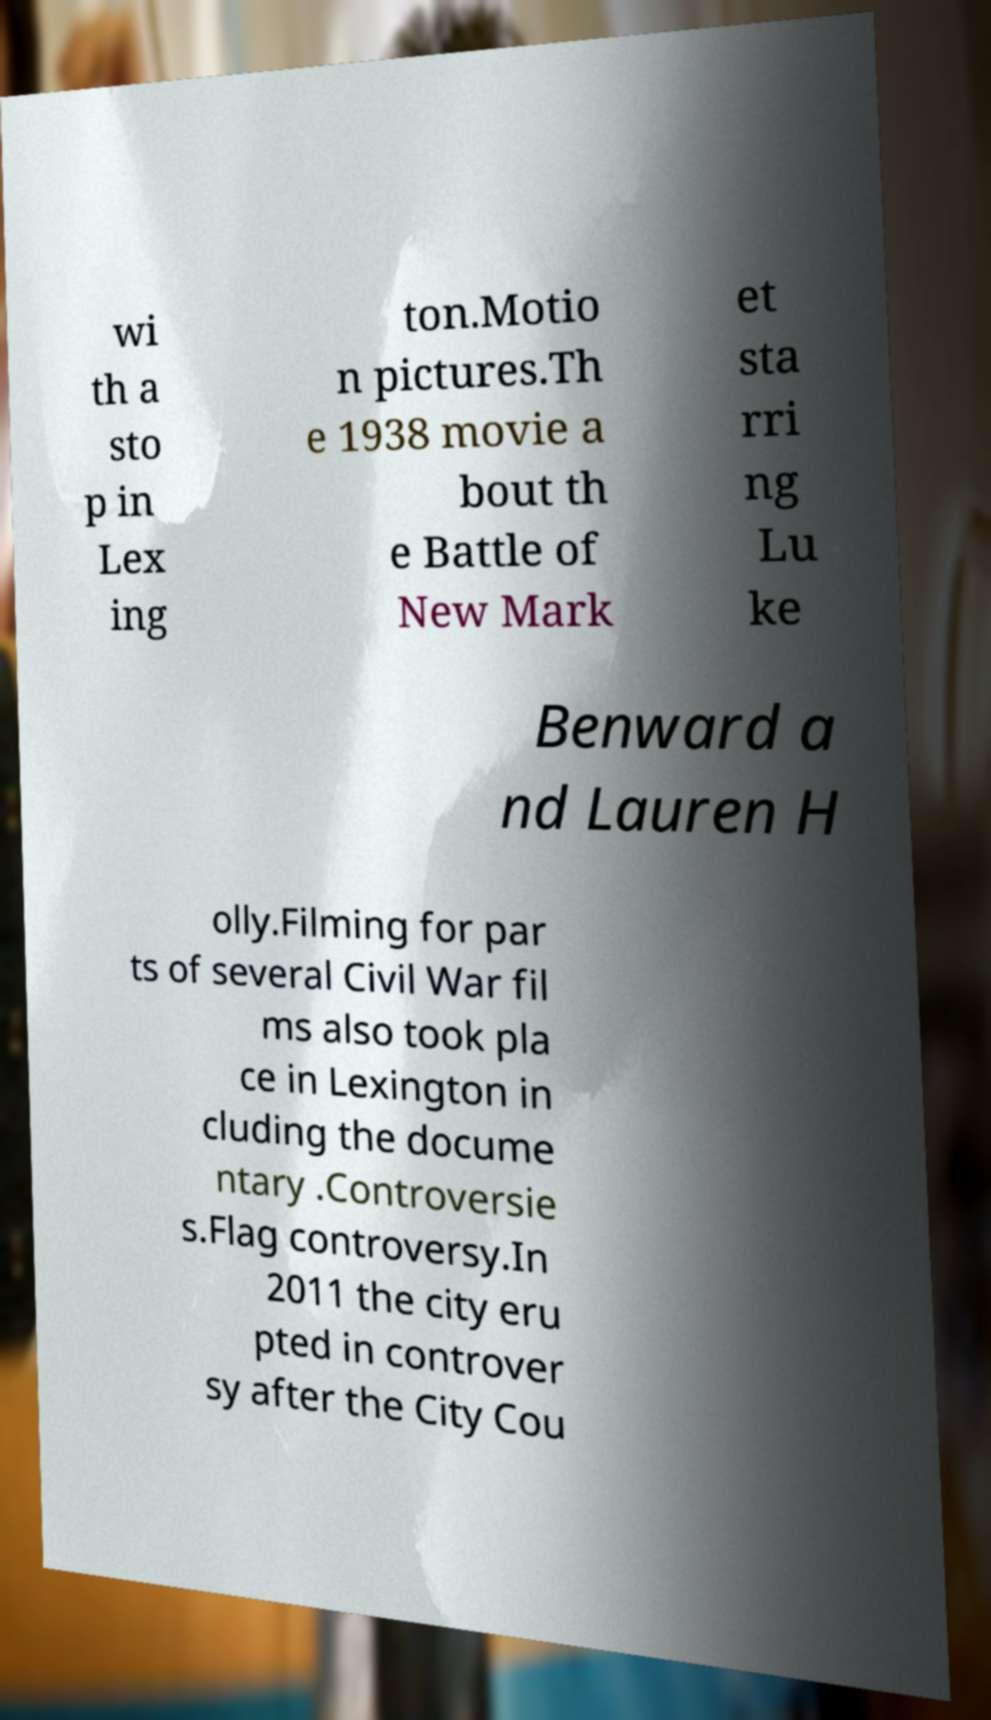There's text embedded in this image that I need extracted. Can you transcribe it verbatim? wi th a sto p in Lex ing ton.Motio n pictures.Th e 1938 movie a bout th e Battle of New Mark et sta rri ng Lu ke Benward a nd Lauren H olly.Filming for par ts of several Civil War fil ms also took pla ce in Lexington in cluding the docume ntary .Controversie s.Flag controversy.In 2011 the city eru pted in controver sy after the City Cou 